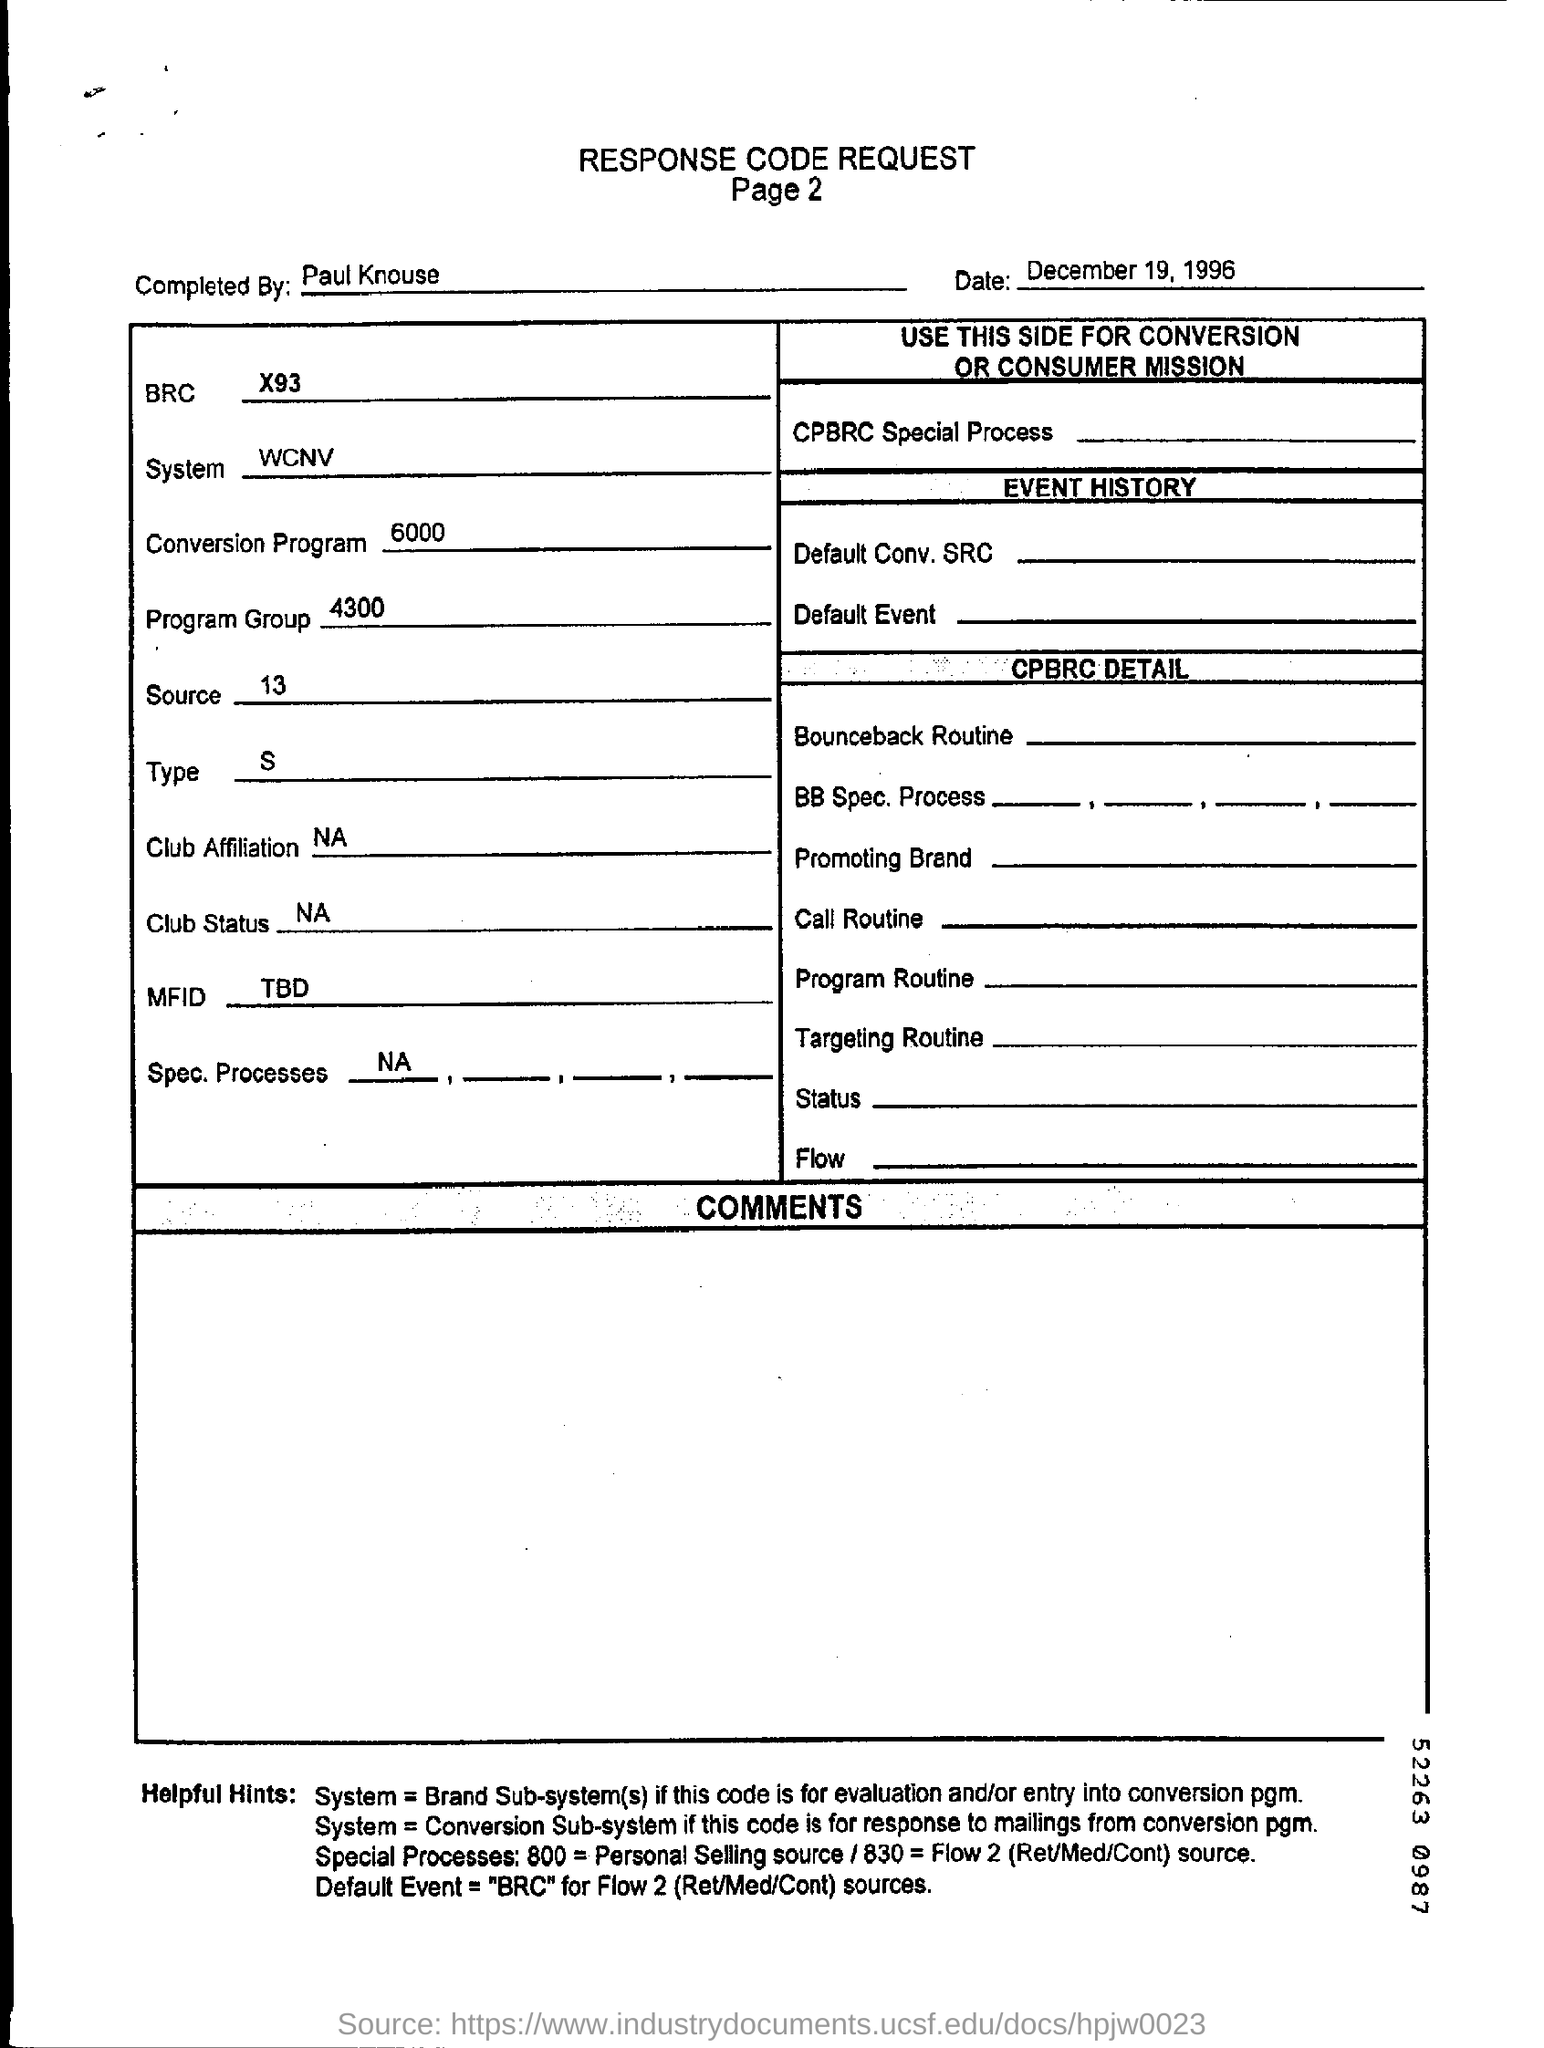Who completed the Response Code Request?
Keep it short and to the point. Paul Knouse. Which System is used as per the document ?
Ensure brevity in your answer.  WCNV. What is the date mentioned in this document?
Provide a short and direct response. December 19, 1996. What is the Conversion program value?
Your answer should be very brief. 6000. What is the page no mentioned in this document?
Your answer should be very brief. Page 2. 